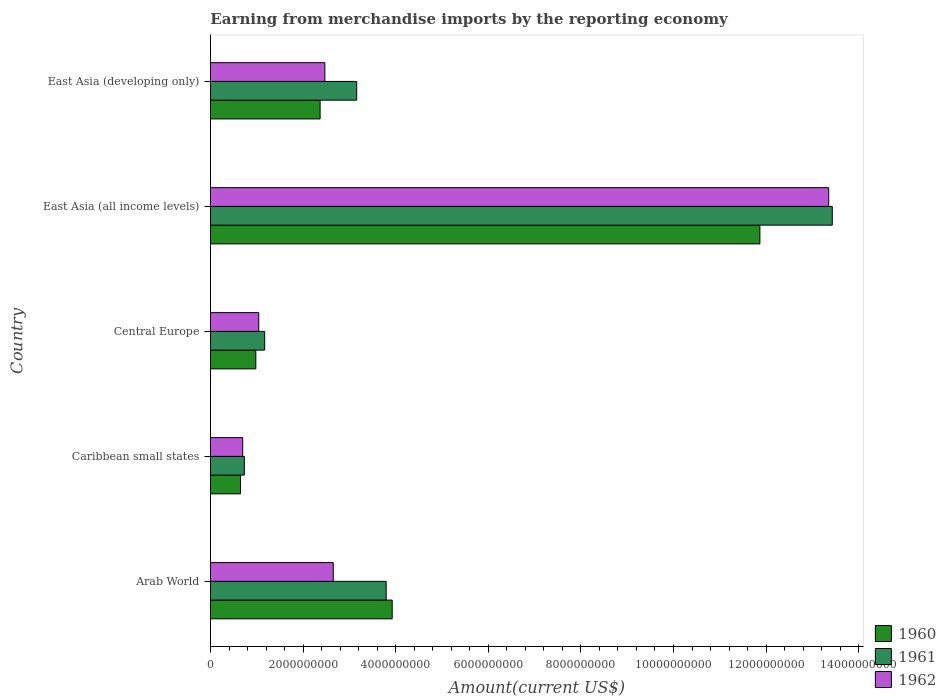How many different coloured bars are there?
Your answer should be compact. 3. How many groups of bars are there?
Offer a very short reply. 5. Are the number of bars on each tick of the Y-axis equal?
Your answer should be compact. Yes. How many bars are there on the 2nd tick from the bottom?
Provide a short and direct response. 3. What is the label of the 2nd group of bars from the top?
Your answer should be very brief. East Asia (all income levels). In how many cases, is the number of bars for a given country not equal to the number of legend labels?
Provide a succinct answer. 0. What is the amount earned from merchandise imports in 1960 in Central Europe?
Give a very brief answer. 9.79e+08. Across all countries, what is the maximum amount earned from merchandise imports in 1960?
Keep it short and to the point. 1.19e+1. Across all countries, what is the minimum amount earned from merchandise imports in 1960?
Make the answer very short. 6.49e+08. In which country was the amount earned from merchandise imports in 1962 maximum?
Offer a very short reply. East Asia (all income levels). In which country was the amount earned from merchandise imports in 1961 minimum?
Offer a terse response. Caribbean small states. What is the total amount earned from merchandise imports in 1960 in the graph?
Make the answer very short. 1.98e+1. What is the difference between the amount earned from merchandise imports in 1960 in Caribbean small states and that in East Asia (developing only)?
Your answer should be compact. -1.72e+09. What is the difference between the amount earned from merchandise imports in 1962 in Caribbean small states and the amount earned from merchandise imports in 1961 in Arab World?
Make the answer very short. -3.10e+09. What is the average amount earned from merchandise imports in 1962 per country?
Provide a short and direct response. 4.04e+09. What is the difference between the amount earned from merchandise imports in 1961 and amount earned from merchandise imports in 1960 in Arab World?
Ensure brevity in your answer.  -1.30e+08. What is the ratio of the amount earned from merchandise imports in 1962 in East Asia (all income levels) to that in East Asia (developing only)?
Your response must be concise. 5.4. Is the amount earned from merchandise imports in 1961 in Arab World less than that in Caribbean small states?
Provide a short and direct response. No. What is the difference between the highest and the second highest amount earned from merchandise imports in 1962?
Keep it short and to the point. 1.07e+1. What is the difference between the highest and the lowest amount earned from merchandise imports in 1961?
Keep it short and to the point. 1.27e+1. What does the 2nd bar from the top in Arab World represents?
Give a very brief answer. 1961. How many bars are there?
Ensure brevity in your answer.  15. Are all the bars in the graph horizontal?
Offer a terse response. Yes. Are the values on the major ticks of X-axis written in scientific E-notation?
Offer a terse response. No. How are the legend labels stacked?
Your response must be concise. Vertical. What is the title of the graph?
Your response must be concise. Earning from merchandise imports by the reporting economy. What is the label or title of the X-axis?
Make the answer very short. Amount(current US$). What is the label or title of the Y-axis?
Offer a very short reply. Country. What is the Amount(current US$) of 1960 in Arab World?
Your response must be concise. 3.92e+09. What is the Amount(current US$) of 1961 in Arab World?
Provide a short and direct response. 3.79e+09. What is the Amount(current US$) of 1962 in Arab World?
Provide a succinct answer. 2.65e+09. What is the Amount(current US$) in 1960 in Caribbean small states?
Your answer should be very brief. 6.49e+08. What is the Amount(current US$) of 1961 in Caribbean small states?
Your answer should be very brief. 7.31e+08. What is the Amount(current US$) in 1962 in Caribbean small states?
Offer a very short reply. 6.96e+08. What is the Amount(current US$) of 1960 in Central Europe?
Give a very brief answer. 9.79e+08. What is the Amount(current US$) in 1961 in Central Europe?
Keep it short and to the point. 1.17e+09. What is the Amount(current US$) in 1962 in Central Europe?
Your response must be concise. 1.04e+09. What is the Amount(current US$) in 1960 in East Asia (all income levels)?
Offer a very short reply. 1.19e+1. What is the Amount(current US$) in 1961 in East Asia (all income levels)?
Your response must be concise. 1.34e+1. What is the Amount(current US$) in 1962 in East Asia (all income levels)?
Offer a very short reply. 1.34e+1. What is the Amount(current US$) in 1960 in East Asia (developing only)?
Ensure brevity in your answer.  2.37e+09. What is the Amount(current US$) in 1961 in East Asia (developing only)?
Make the answer very short. 3.16e+09. What is the Amount(current US$) of 1962 in East Asia (developing only)?
Your response must be concise. 2.47e+09. Across all countries, what is the maximum Amount(current US$) in 1960?
Your answer should be compact. 1.19e+1. Across all countries, what is the maximum Amount(current US$) in 1961?
Make the answer very short. 1.34e+1. Across all countries, what is the maximum Amount(current US$) in 1962?
Ensure brevity in your answer.  1.34e+1. Across all countries, what is the minimum Amount(current US$) in 1960?
Ensure brevity in your answer.  6.49e+08. Across all countries, what is the minimum Amount(current US$) of 1961?
Provide a succinct answer. 7.31e+08. Across all countries, what is the minimum Amount(current US$) of 1962?
Provide a short and direct response. 6.96e+08. What is the total Amount(current US$) of 1960 in the graph?
Make the answer very short. 1.98e+1. What is the total Amount(current US$) of 1961 in the graph?
Ensure brevity in your answer.  2.23e+1. What is the total Amount(current US$) in 1962 in the graph?
Ensure brevity in your answer.  2.02e+1. What is the difference between the Amount(current US$) of 1960 in Arab World and that in Caribbean small states?
Make the answer very short. 3.28e+09. What is the difference between the Amount(current US$) in 1961 in Arab World and that in Caribbean small states?
Keep it short and to the point. 3.06e+09. What is the difference between the Amount(current US$) of 1962 in Arab World and that in Caribbean small states?
Make the answer very short. 1.96e+09. What is the difference between the Amount(current US$) of 1960 in Arab World and that in Central Europe?
Provide a succinct answer. 2.95e+09. What is the difference between the Amount(current US$) in 1961 in Arab World and that in Central Europe?
Give a very brief answer. 2.62e+09. What is the difference between the Amount(current US$) in 1962 in Arab World and that in Central Europe?
Ensure brevity in your answer.  1.61e+09. What is the difference between the Amount(current US$) in 1960 in Arab World and that in East Asia (all income levels)?
Ensure brevity in your answer.  -7.94e+09. What is the difference between the Amount(current US$) of 1961 in Arab World and that in East Asia (all income levels)?
Provide a succinct answer. -9.63e+09. What is the difference between the Amount(current US$) in 1962 in Arab World and that in East Asia (all income levels)?
Provide a succinct answer. -1.07e+1. What is the difference between the Amount(current US$) of 1960 in Arab World and that in East Asia (developing only)?
Keep it short and to the point. 1.56e+09. What is the difference between the Amount(current US$) in 1961 in Arab World and that in East Asia (developing only)?
Keep it short and to the point. 6.36e+08. What is the difference between the Amount(current US$) of 1962 in Arab World and that in East Asia (developing only)?
Your answer should be very brief. 1.81e+08. What is the difference between the Amount(current US$) of 1960 in Caribbean small states and that in Central Europe?
Keep it short and to the point. -3.30e+08. What is the difference between the Amount(current US$) of 1961 in Caribbean small states and that in Central Europe?
Offer a terse response. -4.40e+08. What is the difference between the Amount(current US$) of 1962 in Caribbean small states and that in Central Europe?
Offer a very short reply. -3.46e+08. What is the difference between the Amount(current US$) of 1960 in Caribbean small states and that in East Asia (all income levels)?
Your answer should be very brief. -1.12e+1. What is the difference between the Amount(current US$) of 1961 in Caribbean small states and that in East Asia (all income levels)?
Provide a succinct answer. -1.27e+1. What is the difference between the Amount(current US$) of 1962 in Caribbean small states and that in East Asia (all income levels)?
Offer a very short reply. -1.27e+1. What is the difference between the Amount(current US$) of 1960 in Caribbean small states and that in East Asia (developing only)?
Make the answer very short. -1.72e+09. What is the difference between the Amount(current US$) in 1961 in Caribbean small states and that in East Asia (developing only)?
Ensure brevity in your answer.  -2.43e+09. What is the difference between the Amount(current US$) in 1962 in Caribbean small states and that in East Asia (developing only)?
Offer a very short reply. -1.77e+09. What is the difference between the Amount(current US$) of 1960 in Central Europe and that in East Asia (all income levels)?
Make the answer very short. -1.09e+1. What is the difference between the Amount(current US$) of 1961 in Central Europe and that in East Asia (all income levels)?
Your response must be concise. -1.23e+1. What is the difference between the Amount(current US$) of 1962 in Central Europe and that in East Asia (all income levels)?
Make the answer very short. -1.23e+1. What is the difference between the Amount(current US$) in 1960 in Central Europe and that in East Asia (developing only)?
Offer a very short reply. -1.39e+09. What is the difference between the Amount(current US$) in 1961 in Central Europe and that in East Asia (developing only)?
Provide a short and direct response. -1.99e+09. What is the difference between the Amount(current US$) in 1962 in Central Europe and that in East Asia (developing only)?
Your response must be concise. -1.43e+09. What is the difference between the Amount(current US$) in 1960 in East Asia (all income levels) and that in East Asia (developing only)?
Offer a very short reply. 9.50e+09. What is the difference between the Amount(current US$) of 1961 in East Asia (all income levels) and that in East Asia (developing only)?
Your answer should be compact. 1.03e+1. What is the difference between the Amount(current US$) in 1962 in East Asia (all income levels) and that in East Asia (developing only)?
Make the answer very short. 1.09e+1. What is the difference between the Amount(current US$) in 1960 in Arab World and the Amount(current US$) in 1961 in Caribbean small states?
Give a very brief answer. 3.19e+09. What is the difference between the Amount(current US$) in 1960 in Arab World and the Amount(current US$) in 1962 in Caribbean small states?
Offer a terse response. 3.23e+09. What is the difference between the Amount(current US$) in 1961 in Arab World and the Amount(current US$) in 1962 in Caribbean small states?
Your response must be concise. 3.10e+09. What is the difference between the Amount(current US$) of 1960 in Arab World and the Amount(current US$) of 1961 in Central Europe?
Offer a terse response. 2.75e+09. What is the difference between the Amount(current US$) of 1960 in Arab World and the Amount(current US$) of 1962 in Central Europe?
Provide a succinct answer. 2.88e+09. What is the difference between the Amount(current US$) of 1961 in Arab World and the Amount(current US$) of 1962 in Central Europe?
Your answer should be very brief. 2.75e+09. What is the difference between the Amount(current US$) in 1960 in Arab World and the Amount(current US$) in 1961 in East Asia (all income levels)?
Your answer should be compact. -9.50e+09. What is the difference between the Amount(current US$) in 1960 in Arab World and the Amount(current US$) in 1962 in East Asia (all income levels)?
Give a very brief answer. -9.43e+09. What is the difference between the Amount(current US$) in 1961 in Arab World and the Amount(current US$) in 1962 in East Asia (all income levels)?
Your response must be concise. -9.56e+09. What is the difference between the Amount(current US$) in 1960 in Arab World and the Amount(current US$) in 1961 in East Asia (developing only)?
Keep it short and to the point. 7.67e+08. What is the difference between the Amount(current US$) of 1960 in Arab World and the Amount(current US$) of 1962 in East Asia (developing only)?
Provide a succinct answer. 1.45e+09. What is the difference between the Amount(current US$) of 1961 in Arab World and the Amount(current US$) of 1962 in East Asia (developing only)?
Ensure brevity in your answer.  1.32e+09. What is the difference between the Amount(current US$) of 1960 in Caribbean small states and the Amount(current US$) of 1961 in Central Europe?
Your answer should be very brief. -5.22e+08. What is the difference between the Amount(current US$) of 1960 in Caribbean small states and the Amount(current US$) of 1962 in Central Europe?
Offer a terse response. -3.94e+08. What is the difference between the Amount(current US$) in 1961 in Caribbean small states and the Amount(current US$) in 1962 in Central Europe?
Keep it short and to the point. -3.12e+08. What is the difference between the Amount(current US$) in 1960 in Caribbean small states and the Amount(current US$) in 1961 in East Asia (all income levels)?
Offer a very short reply. -1.28e+1. What is the difference between the Amount(current US$) in 1960 in Caribbean small states and the Amount(current US$) in 1962 in East Asia (all income levels)?
Offer a very short reply. -1.27e+1. What is the difference between the Amount(current US$) in 1961 in Caribbean small states and the Amount(current US$) in 1962 in East Asia (all income levels)?
Keep it short and to the point. -1.26e+1. What is the difference between the Amount(current US$) in 1960 in Caribbean small states and the Amount(current US$) in 1961 in East Asia (developing only)?
Your answer should be compact. -2.51e+09. What is the difference between the Amount(current US$) of 1960 in Caribbean small states and the Amount(current US$) of 1962 in East Asia (developing only)?
Offer a very short reply. -1.82e+09. What is the difference between the Amount(current US$) of 1961 in Caribbean small states and the Amount(current US$) of 1962 in East Asia (developing only)?
Provide a succinct answer. -1.74e+09. What is the difference between the Amount(current US$) of 1960 in Central Europe and the Amount(current US$) of 1961 in East Asia (all income levels)?
Give a very brief answer. -1.24e+1. What is the difference between the Amount(current US$) of 1960 in Central Europe and the Amount(current US$) of 1962 in East Asia (all income levels)?
Your answer should be very brief. -1.24e+1. What is the difference between the Amount(current US$) of 1961 in Central Europe and the Amount(current US$) of 1962 in East Asia (all income levels)?
Give a very brief answer. -1.22e+1. What is the difference between the Amount(current US$) in 1960 in Central Europe and the Amount(current US$) in 1961 in East Asia (developing only)?
Offer a terse response. -2.18e+09. What is the difference between the Amount(current US$) of 1960 in Central Europe and the Amount(current US$) of 1962 in East Asia (developing only)?
Keep it short and to the point. -1.49e+09. What is the difference between the Amount(current US$) in 1961 in Central Europe and the Amount(current US$) in 1962 in East Asia (developing only)?
Provide a short and direct response. -1.30e+09. What is the difference between the Amount(current US$) in 1960 in East Asia (all income levels) and the Amount(current US$) in 1961 in East Asia (developing only)?
Provide a succinct answer. 8.71e+09. What is the difference between the Amount(current US$) in 1960 in East Asia (all income levels) and the Amount(current US$) in 1962 in East Asia (developing only)?
Your answer should be very brief. 9.40e+09. What is the difference between the Amount(current US$) of 1961 in East Asia (all income levels) and the Amount(current US$) of 1962 in East Asia (developing only)?
Provide a succinct answer. 1.10e+1. What is the average Amount(current US$) in 1960 per country?
Your answer should be compact. 3.96e+09. What is the average Amount(current US$) of 1961 per country?
Your answer should be very brief. 4.46e+09. What is the average Amount(current US$) of 1962 per country?
Your response must be concise. 4.04e+09. What is the difference between the Amount(current US$) of 1960 and Amount(current US$) of 1961 in Arab World?
Offer a very short reply. 1.30e+08. What is the difference between the Amount(current US$) in 1960 and Amount(current US$) in 1962 in Arab World?
Your response must be concise. 1.27e+09. What is the difference between the Amount(current US$) in 1961 and Amount(current US$) in 1962 in Arab World?
Your answer should be very brief. 1.14e+09. What is the difference between the Amount(current US$) in 1960 and Amount(current US$) in 1961 in Caribbean small states?
Your response must be concise. -8.18e+07. What is the difference between the Amount(current US$) of 1960 and Amount(current US$) of 1962 in Caribbean small states?
Your answer should be compact. -4.73e+07. What is the difference between the Amount(current US$) of 1961 and Amount(current US$) of 1962 in Caribbean small states?
Keep it short and to the point. 3.45e+07. What is the difference between the Amount(current US$) of 1960 and Amount(current US$) of 1961 in Central Europe?
Ensure brevity in your answer.  -1.92e+08. What is the difference between the Amount(current US$) of 1960 and Amount(current US$) of 1962 in Central Europe?
Give a very brief answer. -6.33e+07. What is the difference between the Amount(current US$) of 1961 and Amount(current US$) of 1962 in Central Europe?
Keep it short and to the point. 1.28e+08. What is the difference between the Amount(current US$) in 1960 and Amount(current US$) in 1961 in East Asia (all income levels)?
Your answer should be very brief. -1.56e+09. What is the difference between the Amount(current US$) of 1960 and Amount(current US$) of 1962 in East Asia (all income levels)?
Provide a short and direct response. -1.49e+09. What is the difference between the Amount(current US$) of 1961 and Amount(current US$) of 1962 in East Asia (all income levels)?
Keep it short and to the point. 7.72e+07. What is the difference between the Amount(current US$) in 1960 and Amount(current US$) in 1961 in East Asia (developing only)?
Your answer should be compact. -7.90e+08. What is the difference between the Amount(current US$) in 1960 and Amount(current US$) in 1962 in East Asia (developing only)?
Give a very brief answer. -1.03e+08. What is the difference between the Amount(current US$) of 1961 and Amount(current US$) of 1962 in East Asia (developing only)?
Your answer should be very brief. 6.88e+08. What is the ratio of the Amount(current US$) of 1960 in Arab World to that in Caribbean small states?
Make the answer very short. 6.05. What is the ratio of the Amount(current US$) of 1961 in Arab World to that in Caribbean small states?
Your answer should be very brief. 5.19. What is the ratio of the Amount(current US$) in 1962 in Arab World to that in Caribbean small states?
Make the answer very short. 3.81. What is the ratio of the Amount(current US$) in 1960 in Arab World to that in Central Europe?
Provide a short and direct response. 4.01. What is the ratio of the Amount(current US$) of 1961 in Arab World to that in Central Europe?
Your response must be concise. 3.24. What is the ratio of the Amount(current US$) of 1962 in Arab World to that in Central Europe?
Provide a short and direct response. 2.54. What is the ratio of the Amount(current US$) of 1960 in Arab World to that in East Asia (all income levels)?
Provide a short and direct response. 0.33. What is the ratio of the Amount(current US$) of 1961 in Arab World to that in East Asia (all income levels)?
Make the answer very short. 0.28. What is the ratio of the Amount(current US$) in 1962 in Arab World to that in East Asia (all income levels)?
Make the answer very short. 0.2. What is the ratio of the Amount(current US$) of 1960 in Arab World to that in East Asia (developing only)?
Ensure brevity in your answer.  1.66. What is the ratio of the Amount(current US$) in 1961 in Arab World to that in East Asia (developing only)?
Your response must be concise. 1.2. What is the ratio of the Amount(current US$) of 1962 in Arab World to that in East Asia (developing only)?
Ensure brevity in your answer.  1.07. What is the ratio of the Amount(current US$) of 1960 in Caribbean small states to that in Central Europe?
Provide a succinct answer. 0.66. What is the ratio of the Amount(current US$) of 1961 in Caribbean small states to that in Central Europe?
Keep it short and to the point. 0.62. What is the ratio of the Amount(current US$) of 1962 in Caribbean small states to that in Central Europe?
Keep it short and to the point. 0.67. What is the ratio of the Amount(current US$) in 1960 in Caribbean small states to that in East Asia (all income levels)?
Your answer should be compact. 0.05. What is the ratio of the Amount(current US$) in 1961 in Caribbean small states to that in East Asia (all income levels)?
Give a very brief answer. 0.05. What is the ratio of the Amount(current US$) in 1962 in Caribbean small states to that in East Asia (all income levels)?
Keep it short and to the point. 0.05. What is the ratio of the Amount(current US$) of 1960 in Caribbean small states to that in East Asia (developing only)?
Ensure brevity in your answer.  0.27. What is the ratio of the Amount(current US$) of 1961 in Caribbean small states to that in East Asia (developing only)?
Your response must be concise. 0.23. What is the ratio of the Amount(current US$) of 1962 in Caribbean small states to that in East Asia (developing only)?
Make the answer very short. 0.28. What is the ratio of the Amount(current US$) of 1960 in Central Europe to that in East Asia (all income levels)?
Keep it short and to the point. 0.08. What is the ratio of the Amount(current US$) in 1961 in Central Europe to that in East Asia (all income levels)?
Offer a terse response. 0.09. What is the ratio of the Amount(current US$) in 1962 in Central Europe to that in East Asia (all income levels)?
Your answer should be very brief. 0.08. What is the ratio of the Amount(current US$) in 1960 in Central Europe to that in East Asia (developing only)?
Your answer should be compact. 0.41. What is the ratio of the Amount(current US$) of 1961 in Central Europe to that in East Asia (developing only)?
Make the answer very short. 0.37. What is the ratio of the Amount(current US$) of 1962 in Central Europe to that in East Asia (developing only)?
Keep it short and to the point. 0.42. What is the ratio of the Amount(current US$) of 1960 in East Asia (all income levels) to that in East Asia (developing only)?
Your answer should be very brief. 5.01. What is the ratio of the Amount(current US$) in 1961 in East Asia (all income levels) to that in East Asia (developing only)?
Your answer should be very brief. 4.25. What is the ratio of the Amount(current US$) of 1962 in East Asia (all income levels) to that in East Asia (developing only)?
Offer a terse response. 5.4. What is the difference between the highest and the second highest Amount(current US$) of 1960?
Ensure brevity in your answer.  7.94e+09. What is the difference between the highest and the second highest Amount(current US$) of 1961?
Your answer should be very brief. 9.63e+09. What is the difference between the highest and the second highest Amount(current US$) in 1962?
Provide a short and direct response. 1.07e+1. What is the difference between the highest and the lowest Amount(current US$) in 1960?
Make the answer very short. 1.12e+1. What is the difference between the highest and the lowest Amount(current US$) in 1961?
Ensure brevity in your answer.  1.27e+1. What is the difference between the highest and the lowest Amount(current US$) in 1962?
Make the answer very short. 1.27e+1. 